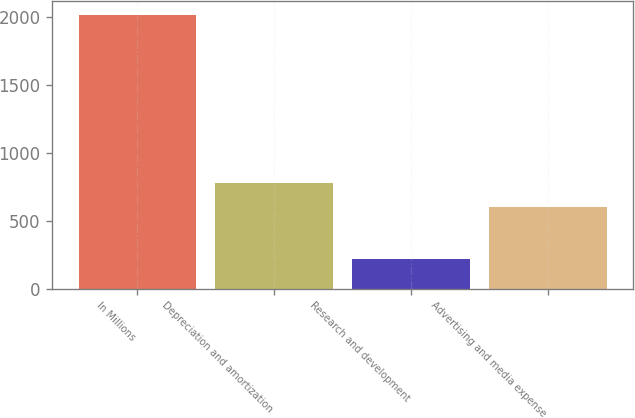Convert chart to OTSL. <chart><loc_0><loc_0><loc_500><loc_500><bar_chart><fcel>In Millions<fcel>Depreciation and amortization<fcel>Research and development<fcel>Advertising and media expense<nl><fcel>2019<fcel>781.31<fcel>221.9<fcel>601.6<nl></chart> 